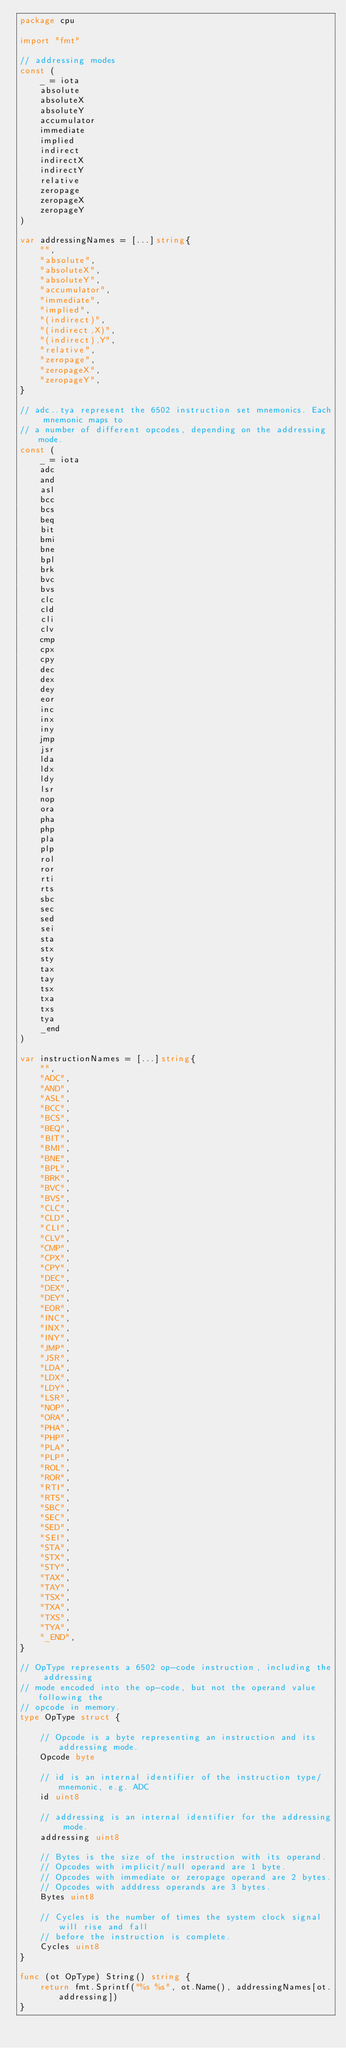Convert code to text. <code><loc_0><loc_0><loc_500><loc_500><_Go_>package cpu

import "fmt"

// addressing modes
const (
	_ = iota
	absolute
	absoluteX
	absoluteY
	accumulator
	immediate
	implied
	indirect
	indirectX
	indirectY
	relative
	zeropage
	zeropageX
	zeropageY
)

var addressingNames = [...]string{
	"",
	"absolute",
	"absoluteX",
	"absoluteY",
	"accumulator",
	"immediate",
	"implied",
	"(indirect)",
	"(indirect,X)",
	"(indirect),Y",
	"relative",
	"zeropage",
	"zeropageX",
	"zeropageY",
}

// adc..tya represent the 6502 instruction set mnemonics. Each mnemonic maps to
// a number of different opcodes, depending on the addressing mode.
const (
	_ = iota
	adc
	and
	asl
	bcc
	bcs
	beq
	bit
	bmi
	bne
	bpl
	brk
	bvc
	bvs
	clc
	cld
	cli
	clv
	cmp
	cpx
	cpy
	dec
	dex
	dey
	eor
	inc
	inx
	iny
	jmp
	jsr
	lda
	ldx
	ldy
	lsr
	nop
	ora
	pha
	php
	pla
	plp
	rol
	ror
	rti
	rts
	sbc
	sec
	sed
	sei
	sta
	stx
	sty
	tax
	tay
	tsx
	txa
	txs
	tya
	_end
)

var instructionNames = [...]string{
	"",
	"ADC",
	"AND",
	"ASL",
	"BCC",
	"BCS",
	"BEQ",
	"BIT",
	"BMI",
	"BNE",
	"BPL",
	"BRK",
	"BVC",
	"BVS",
	"CLC",
	"CLD",
	"CLI",
	"CLV",
	"CMP",
	"CPX",
	"CPY",
	"DEC",
	"DEX",
	"DEY",
	"EOR",
	"INC",
	"INX",
	"INY",
	"JMP",
	"JSR",
	"LDA",
	"LDX",
	"LDY",
	"LSR",
	"NOP",
	"ORA",
	"PHA",
	"PHP",
	"PLA",
	"PLP",
	"ROL",
	"ROR",
	"RTI",
	"RTS",
	"SBC",
	"SEC",
	"SED",
	"SEI",
	"STA",
	"STX",
	"STY",
	"TAX",
	"TAY",
	"TSX",
	"TXA",
	"TXS",
	"TYA",
	"_END",
}

// OpType represents a 6502 op-code instruction, including the addressing
// mode encoded into the op-code, but not the operand value following the
// opcode in memory.
type OpType struct {

	// Opcode is a byte representing an instruction and its addressing mode.
	Opcode byte

	// id is an internal identifier of the instruction type/mnemonic, e.g. ADC
	id uint8

	// addressing is an internal identifier for the addressing mode.
	addressing uint8

	// Bytes is the size of the instruction with its operand.
	// Opcodes with implicit/null operand are 1 byte.
	// Opcodes with immediate or zeropage operand are 2 bytes.
	// Opcodes with adddress operands are 3 bytes.
	Bytes uint8

	// Cycles is the number of times the system clock signal will rise and fall
	// before the instruction is complete.
	Cycles uint8
}

func (ot OpType) String() string {
	return fmt.Sprintf("%s %s", ot.Name(), addressingNames[ot.addressing])
}
</code> 